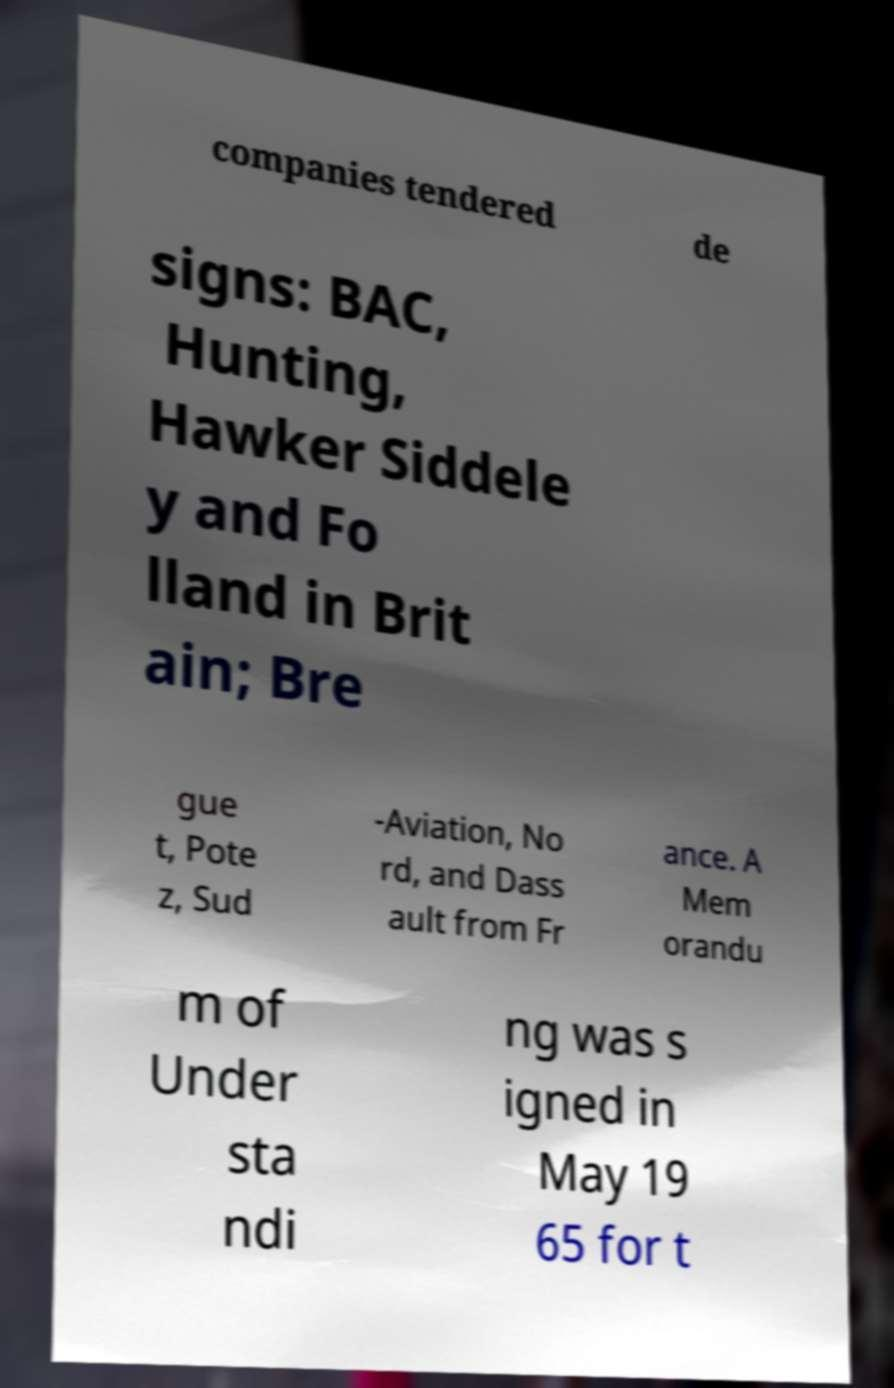Could you assist in decoding the text presented in this image and type it out clearly? companies tendered de signs: BAC, Hunting, Hawker Siddele y and Fo lland in Brit ain; Bre gue t, Pote z, Sud -Aviation, No rd, and Dass ault from Fr ance. A Mem orandu m of Under sta ndi ng was s igned in May 19 65 for t 